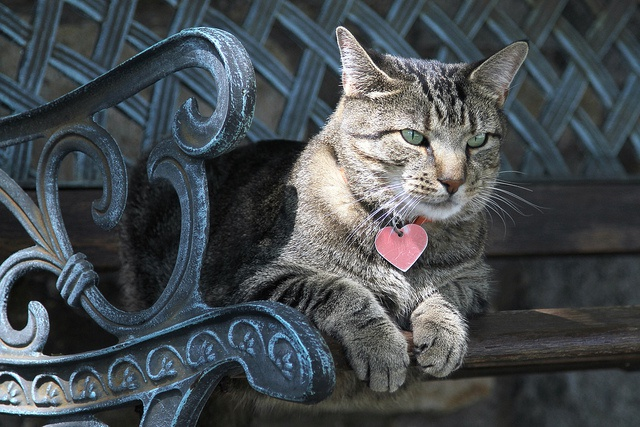Describe the objects in this image and their specific colors. I can see bench in black, blue, and darkblue tones, cat in black, gray, darkgray, and lightgray tones, and bench in black and gray tones in this image. 